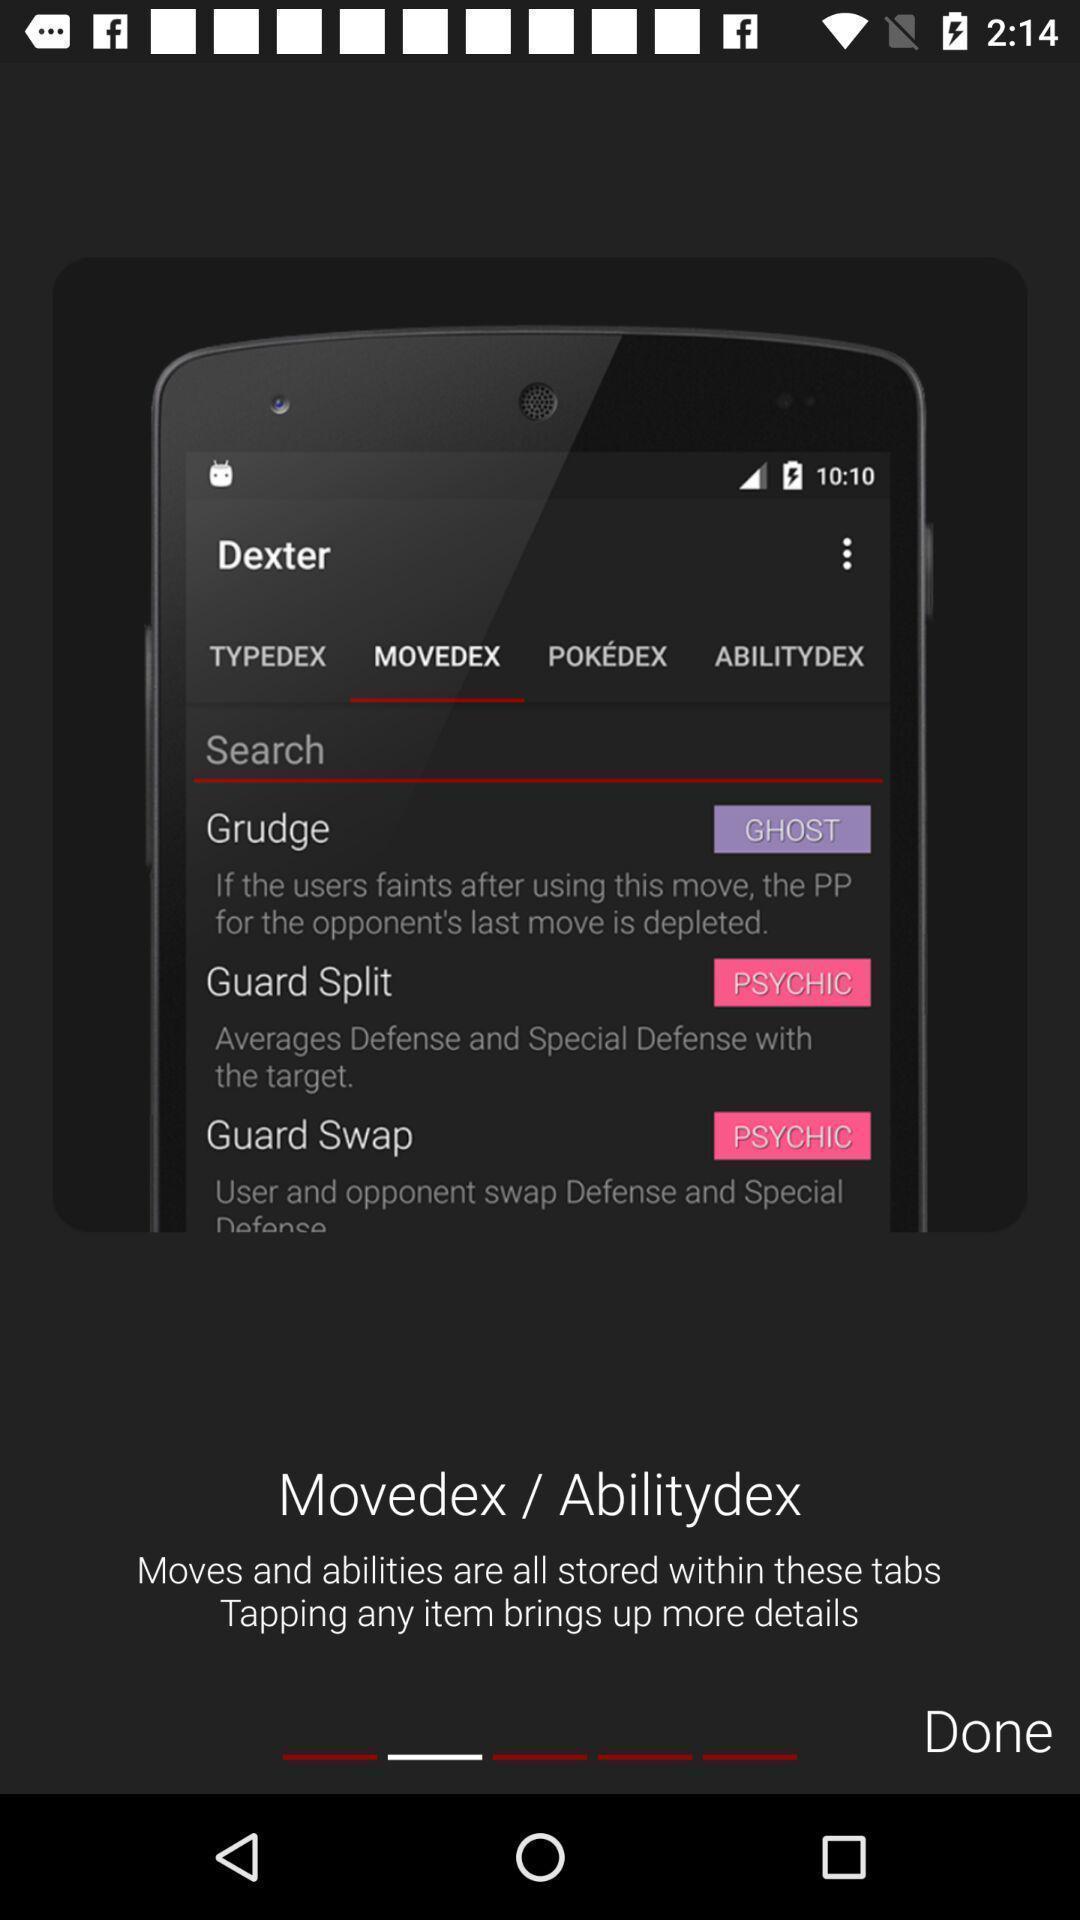What details can you identify in this image? Screen displaying the multiple features. 